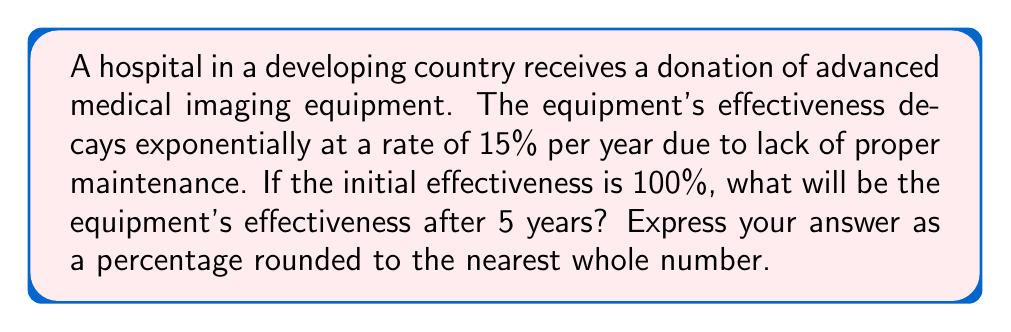Teach me how to tackle this problem. Let's approach this step-by-step:

1) The decay of the equipment's effectiveness follows an exponential decay model:

   $A(t) = A_0 \cdot (1-r)^t$

   Where:
   $A(t)$ is the effectiveness at time $t$
   $A_0$ is the initial effectiveness
   $r$ is the decay rate
   $t$ is the time in years

2) We're given:
   $A_0 = 100\%$
   $r = 15\% = 0.15$
   $t = 5$ years

3) Let's substitute these values into our equation:

   $A(5) = 100 \cdot (1-0.15)^5$

4) Simplify inside the parentheses:
   
   $A(5) = 100 \cdot (0.85)^5$

5) Calculate the power:
   
   $A(5) = 100 \cdot 0.4437$

6) Multiply:
   
   $A(5) = 44.37\%$

7) Rounding to the nearest whole number:
   
   $A(5) \approx 44\%$
Answer: 44% 